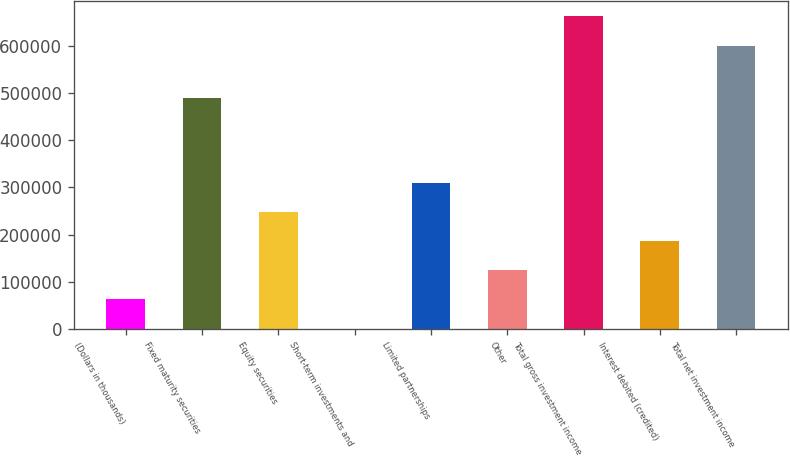Convert chart to OTSL. <chart><loc_0><loc_0><loc_500><loc_500><bar_chart><fcel>(Dollars in thousands)<fcel>Fixed maturity securities<fcel>Equity securities<fcel>Short-term investments and<fcel>Limited partnerships<fcel>Other<fcel>Total gross investment income<fcel>Interest debited (credited)<fcel>Total net investment income<nl><fcel>63022.4<fcel>489801<fcel>248334<fcel>1252<fcel>310104<fcel>124793<fcel>661972<fcel>186563<fcel>600202<nl></chart> 